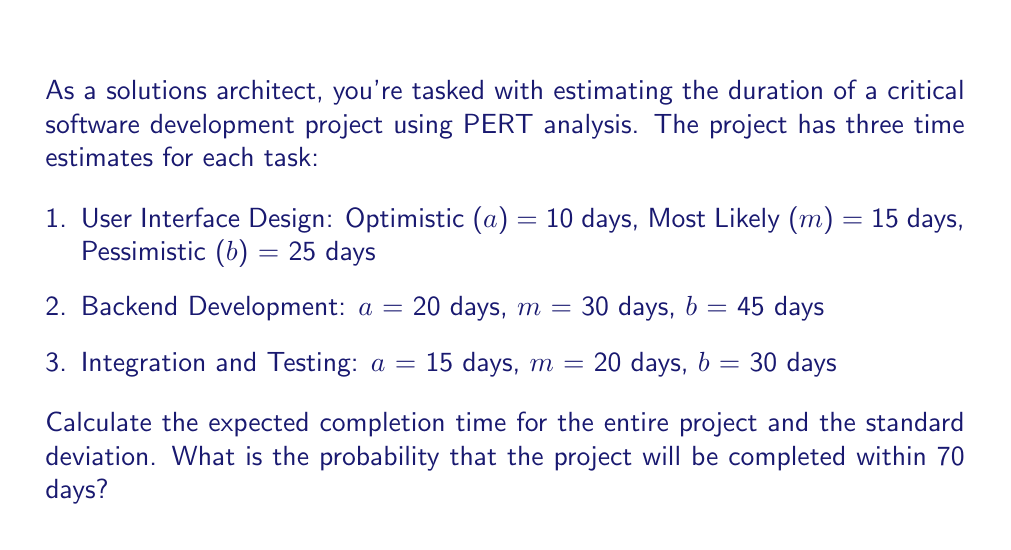Help me with this question. Let's approach this step-by-step:

1. Calculate the expected time (TE) for each task using the PERT formula:
   $$ TE = \frac{a + 4m + b}{6} $$

   Task 1: $TE_1 = \frac{10 + 4(15) + 25}{6} = \frac{110}{6} = 18.33$ days
   Task 2: $TE_2 = \frac{20 + 4(30) + 45}{6} = \frac{185}{6} = 30.83$ days
   Task 3: $TE_3 = \frac{15 + 4(20) + 30}{6} = \frac{125}{6} = 20.83$ days

2. Calculate the total expected project duration:
   $$ TE_{total} = TE_1 + TE_2 + TE_3 = 18.33 + 30.83 + 20.83 = 69.99 \approx 70 \text{ days} $$

3. Calculate the variance for each task:
   $$ Variance = (\frac{b - a}{6})^2 $$

   Task 1: $V_1 = (\frac{25 - 10}{6})^2 = 6.25$
   Task 2: $V_2 = (\frac{45 - 20}{6})^2 = 17.36$
   Task 3: $V_3 = (\frac{30 - 15}{6})^2 = 6.25$

4. Calculate the total project variance:
   $$ V_{total} = V_1 + V_2 + V_3 = 6.25 + 17.36 + 6.25 = 29.86 $$

5. Calculate the standard deviation:
   $$ \sigma = \sqrt{V_{total}} = \sqrt{29.86} = 5.46 \text{ days} $$

6. To find the probability of completing within 70 days, we need to calculate the Z-score:
   $$ Z = \frac{X - \mu}{\sigma} = \frac{70 - 69.99}{5.46} = 0.0018 $$

7. Using a standard normal distribution table or calculator, we find that the probability of Z ≤ 0.0018 is approximately 0.5007 or 50.07%.

Therefore, the probability that the project will be completed within 70 days is about 50.07%.
Answer: Expected completion time: 70 days
Standard deviation: 5.46 days
Probability of completion within 70 days: 50.07% 